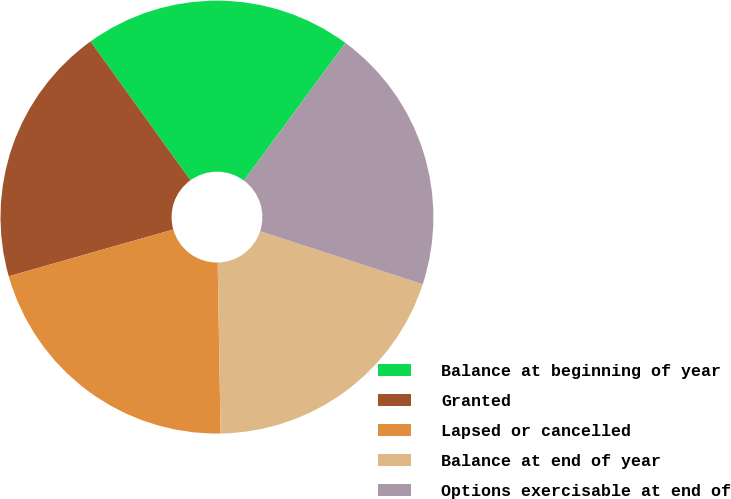<chart> <loc_0><loc_0><loc_500><loc_500><pie_chart><fcel>Balance at beginning of year<fcel>Granted<fcel>Lapsed or cancelled<fcel>Balance at end of year<fcel>Options exercisable at end of<nl><fcel>20.05%<fcel>19.48%<fcel>20.86%<fcel>19.72%<fcel>19.9%<nl></chart> 